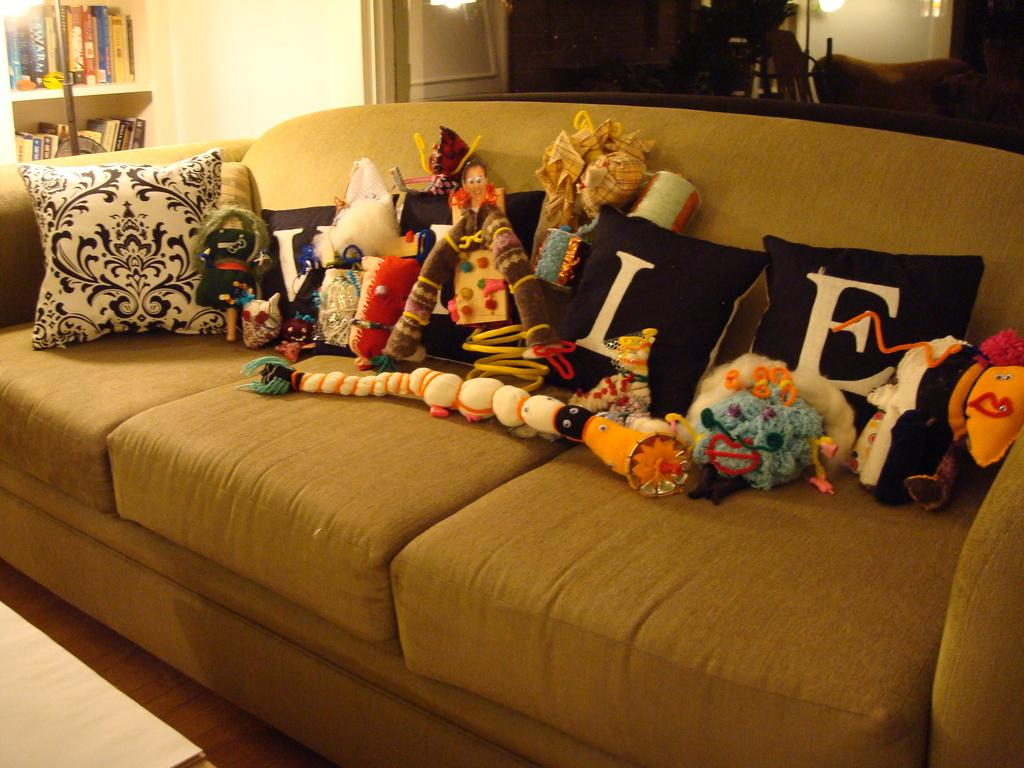What type of furniture is present in the image? There is a sofa in the image. What is placed on the sofa? There are cushions and soft toys on the sofa. What can be seen in the background of the image? There are books and lights in the background of the image. How many boats are visible in the image? There are no boats present in the image. What type of net is being used to catch the soft toys on the sofa? There is no net visible in the image, and the soft toys are not being caught. 